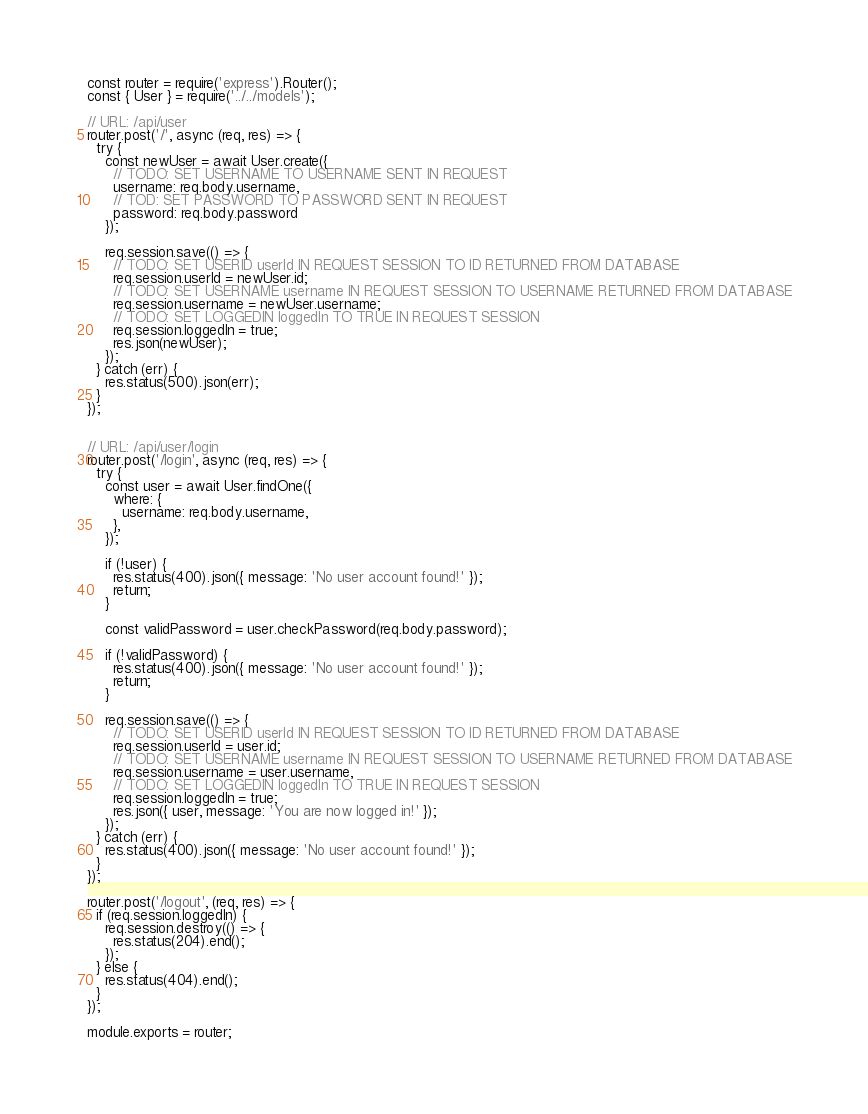Convert code to text. <code><loc_0><loc_0><loc_500><loc_500><_JavaScript_>const router = require('express').Router();
const { User } = require('../../models');

// URL: /api/user
router.post('/', async (req, res) => {
  try {
    const newUser = await User.create({
      // TODO: SET USERNAME TO USERNAME SENT IN REQUEST
      username: req.body.username,
      // TOD: SET PASSWORD TO PASSWORD SENT IN REQUEST
      password: req.body.password
    });

    req.session.save(() => {
      // TODO: SET USERID userId IN REQUEST SESSION TO ID RETURNED FROM DATABASE
      req.session.userId = newUser.id;
      // TODO: SET USERNAME username IN REQUEST SESSION TO USERNAME RETURNED FROM DATABASE
      req.session.username = newUser.username;
      // TODO: SET LOGGEDIN loggedIn TO TRUE IN REQUEST SESSION
      req.session.loggedIn = true;
      res.json(newUser);
    });
  } catch (err) {
    res.status(500).json(err);
  }
});


// URL: /api/user/login
router.post('/login', async (req, res) => {
  try {
    const user = await User.findOne({
      where: {
        username: req.body.username,
      },
    });

    if (!user) {
      res.status(400).json({ message: 'No user account found!' });
      return;
    }

    const validPassword = user.checkPassword(req.body.password);

    if (!validPassword) {
      res.status(400).json({ message: 'No user account found!' });
      return;
    }

    req.session.save(() => {
      // TODO: SET USERID userId IN REQUEST SESSION TO ID RETURNED FROM DATABASE
      req.session.userId = user.id;
      // TODO: SET USERNAME username IN REQUEST SESSION TO USERNAME RETURNED FROM DATABASE
      req.session.username = user.username,
      // TODO: SET LOGGEDIN loggedIn TO TRUE IN REQUEST SESSION
      req.session.loggedIn = true;
      res.json({ user, message: 'You are now logged in!' });
    });
  } catch (err) {
    res.status(400).json({ message: 'No user account found!' });
  }
});

router.post('/logout', (req, res) => {
  if (req.session.loggedIn) {
    req.session.destroy(() => {
      res.status(204).end();
    });
  } else {
    res.status(404).end();
  }
});

module.exports = router;
</code> 